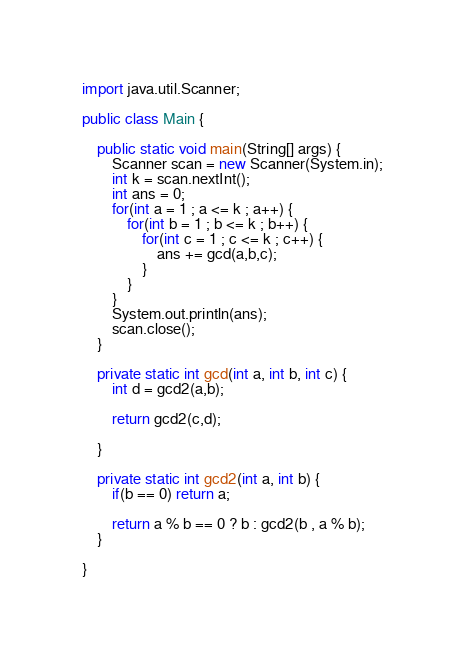<code> <loc_0><loc_0><loc_500><loc_500><_Java_>import java.util.Scanner;

public class Main {

	public static void main(String[] args) {
		Scanner scan = new Scanner(System.in);
		int k = scan.nextInt();
		int ans = 0;
		for(int a = 1 ; a <= k ; a++) {
			for(int b = 1 ; b <= k ; b++) {
				for(int c = 1 ; c <= k ; c++) {
					ans += gcd(a,b,c);
				}
			}
		}
		System.out.println(ans);
		scan.close();
	}

	private static int gcd(int a, int b, int c) {
		int d = gcd2(a,b);
		
		return gcd2(c,d);
		
	}

	private static int gcd2(int a, int b) {
		if(b == 0) return a;
		
		return a % b == 0 ? b : gcd2(b , a % b);
	}

}
</code> 